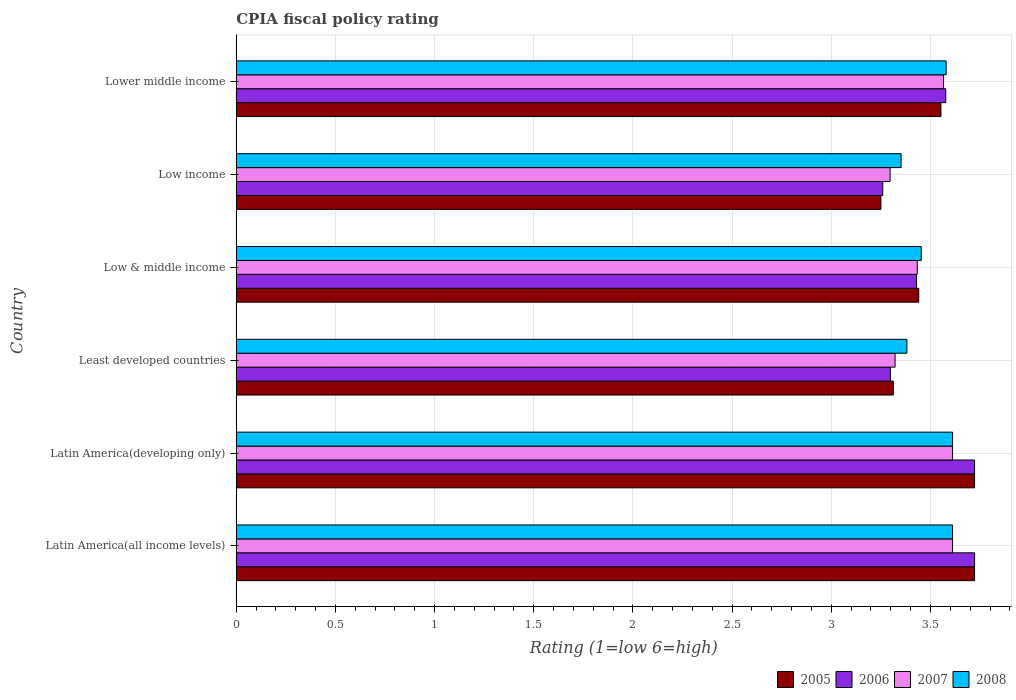How many different coloured bars are there?
Provide a succinct answer. 4. How many groups of bars are there?
Provide a short and direct response. 6. Are the number of bars on each tick of the Y-axis equal?
Give a very brief answer. Yes. What is the label of the 2nd group of bars from the top?
Provide a succinct answer. Low income. In how many cases, is the number of bars for a given country not equal to the number of legend labels?
Your answer should be very brief. 0. What is the CPIA rating in 2007 in Low income?
Provide a short and direct response. 3.3. Across all countries, what is the maximum CPIA rating in 2007?
Offer a terse response. 3.61. Across all countries, what is the minimum CPIA rating in 2008?
Your answer should be compact. 3.35. In which country was the CPIA rating in 2006 maximum?
Keep it short and to the point. Latin America(all income levels). What is the total CPIA rating in 2008 in the graph?
Provide a short and direct response. 20.99. What is the difference between the CPIA rating in 2005 in Low & middle income and that in Lower middle income?
Give a very brief answer. -0.11. What is the difference between the CPIA rating in 2005 in Latin America(developing only) and the CPIA rating in 2008 in Low income?
Provide a short and direct response. 0.37. What is the average CPIA rating in 2006 per country?
Provide a succinct answer. 3.5. What is the difference between the CPIA rating in 2008 and CPIA rating in 2005 in Lower middle income?
Give a very brief answer. 0.03. In how many countries, is the CPIA rating in 2008 greater than 2.1 ?
Offer a very short reply. 6. What is the ratio of the CPIA rating in 2006 in Latin America(all income levels) to that in Low income?
Your answer should be compact. 1.14. Is the CPIA rating in 2005 in Latin America(all income levels) less than that in Lower middle income?
Give a very brief answer. No. What is the difference between the highest and the second highest CPIA rating in 2007?
Your response must be concise. 0. What is the difference between the highest and the lowest CPIA rating in 2005?
Give a very brief answer. 0.47. Is the sum of the CPIA rating in 2006 in Low income and Lower middle income greater than the maximum CPIA rating in 2005 across all countries?
Give a very brief answer. Yes. Is it the case that in every country, the sum of the CPIA rating in 2008 and CPIA rating in 2006 is greater than the sum of CPIA rating in 2007 and CPIA rating in 2005?
Provide a short and direct response. Yes. What does the 4th bar from the top in Least developed countries represents?
Give a very brief answer. 2005. What is the difference between two consecutive major ticks on the X-axis?
Keep it short and to the point. 0.5. Does the graph contain grids?
Give a very brief answer. Yes. Where does the legend appear in the graph?
Offer a terse response. Bottom right. How are the legend labels stacked?
Offer a very short reply. Horizontal. What is the title of the graph?
Your response must be concise. CPIA fiscal policy rating. What is the Rating (1=low 6=high) of 2005 in Latin America(all income levels)?
Ensure brevity in your answer.  3.72. What is the Rating (1=low 6=high) of 2006 in Latin America(all income levels)?
Offer a terse response. 3.72. What is the Rating (1=low 6=high) of 2007 in Latin America(all income levels)?
Ensure brevity in your answer.  3.61. What is the Rating (1=low 6=high) of 2008 in Latin America(all income levels)?
Offer a very short reply. 3.61. What is the Rating (1=low 6=high) of 2005 in Latin America(developing only)?
Provide a succinct answer. 3.72. What is the Rating (1=low 6=high) in 2006 in Latin America(developing only)?
Provide a short and direct response. 3.72. What is the Rating (1=low 6=high) in 2007 in Latin America(developing only)?
Provide a succinct answer. 3.61. What is the Rating (1=low 6=high) of 2008 in Latin America(developing only)?
Give a very brief answer. 3.61. What is the Rating (1=low 6=high) in 2005 in Least developed countries?
Ensure brevity in your answer.  3.31. What is the Rating (1=low 6=high) in 2006 in Least developed countries?
Make the answer very short. 3.3. What is the Rating (1=low 6=high) in 2007 in Least developed countries?
Your answer should be very brief. 3.32. What is the Rating (1=low 6=high) in 2008 in Least developed countries?
Ensure brevity in your answer.  3.38. What is the Rating (1=low 6=high) in 2005 in Low & middle income?
Provide a succinct answer. 3.44. What is the Rating (1=low 6=high) of 2006 in Low & middle income?
Offer a terse response. 3.43. What is the Rating (1=low 6=high) in 2007 in Low & middle income?
Offer a very short reply. 3.43. What is the Rating (1=low 6=high) in 2008 in Low & middle income?
Offer a very short reply. 3.45. What is the Rating (1=low 6=high) in 2005 in Low income?
Provide a succinct answer. 3.25. What is the Rating (1=low 6=high) of 2006 in Low income?
Your answer should be very brief. 3.26. What is the Rating (1=low 6=high) of 2007 in Low income?
Provide a succinct answer. 3.3. What is the Rating (1=low 6=high) in 2008 in Low income?
Keep it short and to the point. 3.35. What is the Rating (1=low 6=high) in 2005 in Lower middle income?
Provide a short and direct response. 3.55. What is the Rating (1=low 6=high) in 2006 in Lower middle income?
Give a very brief answer. 3.58. What is the Rating (1=low 6=high) of 2007 in Lower middle income?
Keep it short and to the point. 3.57. What is the Rating (1=low 6=high) in 2008 in Lower middle income?
Your answer should be very brief. 3.58. Across all countries, what is the maximum Rating (1=low 6=high) in 2005?
Give a very brief answer. 3.72. Across all countries, what is the maximum Rating (1=low 6=high) of 2006?
Make the answer very short. 3.72. Across all countries, what is the maximum Rating (1=low 6=high) in 2007?
Offer a very short reply. 3.61. Across all countries, what is the maximum Rating (1=low 6=high) of 2008?
Give a very brief answer. 3.61. Across all countries, what is the minimum Rating (1=low 6=high) of 2006?
Ensure brevity in your answer.  3.26. Across all countries, what is the minimum Rating (1=low 6=high) of 2007?
Your answer should be very brief. 3.3. Across all countries, what is the minimum Rating (1=low 6=high) in 2008?
Your answer should be compact. 3.35. What is the total Rating (1=low 6=high) of 2005 in the graph?
Offer a very short reply. 21. What is the total Rating (1=low 6=high) in 2006 in the graph?
Your answer should be very brief. 21.01. What is the total Rating (1=low 6=high) of 2007 in the graph?
Provide a short and direct response. 20.84. What is the total Rating (1=low 6=high) of 2008 in the graph?
Offer a very short reply. 20.99. What is the difference between the Rating (1=low 6=high) of 2006 in Latin America(all income levels) and that in Latin America(developing only)?
Offer a very short reply. 0. What is the difference between the Rating (1=low 6=high) of 2008 in Latin America(all income levels) and that in Latin America(developing only)?
Provide a short and direct response. 0. What is the difference between the Rating (1=low 6=high) in 2005 in Latin America(all income levels) and that in Least developed countries?
Give a very brief answer. 0.41. What is the difference between the Rating (1=low 6=high) of 2006 in Latin America(all income levels) and that in Least developed countries?
Your answer should be very brief. 0.42. What is the difference between the Rating (1=low 6=high) in 2007 in Latin America(all income levels) and that in Least developed countries?
Your answer should be compact. 0.29. What is the difference between the Rating (1=low 6=high) in 2008 in Latin America(all income levels) and that in Least developed countries?
Provide a short and direct response. 0.23. What is the difference between the Rating (1=low 6=high) of 2005 in Latin America(all income levels) and that in Low & middle income?
Your response must be concise. 0.28. What is the difference between the Rating (1=low 6=high) of 2006 in Latin America(all income levels) and that in Low & middle income?
Provide a succinct answer. 0.29. What is the difference between the Rating (1=low 6=high) in 2007 in Latin America(all income levels) and that in Low & middle income?
Make the answer very short. 0.18. What is the difference between the Rating (1=low 6=high) of 2008 in Latin America(all income levels) and that in Low & middle income?
Make the answer very short. 0.16. What is the difference between the Rating (1=low 6=high) in 2005 in Latin America(all income levels) and that in Low income?
Ensure brevity in your answer.  0.47. What is the difference between the Rating (1=low 6=high) of 2006 in Latin America(all income levels) and that in Low income?
Offer a very short reply. 0.46. What is the difference between the Rating (1=low 6=high) of 2007 in Latin America(all income levels) and that in Low income?
Your answer should be very brief. 0.31. What is the difference between the Rating (1=low 6=high) in 2008 in Latin America(all income levels) and that in Low income?
Offer a terse response. 0.26. What is the difference between the Rating (1=low 6=high) in 2005 in Latin America(all income levels) and that in Lower middle income?
Your answer should be very brief. 0.17. What is the difference between the Rating (1=low 6=high) in 2006 in Latin America(all income levels) and that in Lower middle income?
Offer a terse response. 0.15. What is the difference between the Rating (1=low 6=high) in 2007 in Latin America(all income levels) and that in Lower middle income?
Your response must be concise. 0.05. What is the difference between the Rating (1=low 6=high) of 2008 in Latin America(all income levels) and that in Lower middle income?
Provide a succinct answer. 0.03. What is the difference between the Rating (1=low 6=high) in 2005 in Latin America(developing only) and that in Least developed countries?
Your answer should be compact. 0.41. What is the difference between the Rating (1=low 6=high) in 2006 in Latin America(developing only) and that in Least developed countries?
Keep it short and to the point. 0.42. What is the difference between the Rating (1=low 6=high) of 2007 in Latin America(developing only) and that in Least developed countries?
Keep it short and to the point. 0.29. What is the difference between the Rating (1=low 6=high) in 2008 in Latin America(developing only) and that in Least developed countries?
Offer a very short reply. 0.23. What is the difference between the Rating (1=low 6=high) of 2005 in Latin America(developing only) and that in Low & middle income?
Offer a terse response. 0.28. What is the difference between the Rating (1=low 6=high) in 2006 in Latin America(developing only) and that in Low & middle income?
Provide a succinct answer. 0.29. What is the difference between the Rating (1=low 6=high) in 2007 in Latin America(developing only) and that in Low & middle income?
Offer a terse response. 0.18. What is the difference between the Rating (1=low 6=high) in 2008 in Latin America(developing only) and that in Low & middle income?
Offer a very short reply. 0.16. What is the difference between the Rating (1=low 6=high) in 2005 in Latin America(developing only) and that in Low income?
Your answer should be very brief. 0.47. What is the difference between the Rating (1=low 6=high) in 2006 in Latin America(developing only) and that in Low income?
Your answer should be compact. 0.46. What is the difference between the Rating (1=low 6=high) in 2007 in Latin America(developing only) and that in Low income?
Your response must be concise. 0.31. What is the difference between the Rating (1=low 6=high) in 2008 in Latin America(developing only) and that in Low income?
Offer a terse response. 0.26. What is the difference between the Rating (1=low 6=high) in 2005 in Latin America(developing only) and that in Lower middle income?
Keep it short and to the point. 0.17. What is the difference between the Rating (1=low 6=high) in 2006 in Latin America(developing only) and that in Lower middle income?
Keep it short and to the point. 0.15. What is the difference between the Rating (1=low 6=high) of 2007 in Latin America(developing only) and that in Lower middle income?
Offer a very short reply. 0.05. What is the difference between the Rating (1=low 6=high) in 2008 in Latin America(developing only) and that in Lower middle income?
Offer a terse response. 0.03. What is the difference between the Rating (1=low 6=high) of 2005 in Least developed countries and that in Low & middle income?
Ensure brevity in your answer.  -0.13. What is the difference between the Rating (1=low 6=high) in 2006 in Least developed countries and that in Low & middle income?
Ensure brevity in your answer.  -0.13. What is the difference between the Rating (1=low 6=high) in 2007 in Least developed countries and that in Low & middle income?
Provide a succinct answer. -0.11. What is the difference between the Rating (1=low 6=high) of 2008 in Least developed countries and that in Low & middle income?
Offer a terse response. -0.07. What is the difference between the Rating (1=low 6=high) of 2005 in Least developed countries and that in Low income?
Offer a terse response. 0.06. What is the difference between the Rating (1=low 6=high) in 2006 in Least developed countries and that in Low income?
Make the answer very short. 0.04. What is the difference between the Rating (1=low 6=high) in 2007 in Least developed countries and that in Low income?
Make the answer very short. 0.03. What is the difference between the Rating (1=low 6=high) in 2008 in Least developed countries and that in Low income?
Make the answer very short. 0.03. What is the difference between the Rating (1=low 6=high) in 2005 in Least developed countries and that in Lower middle income?
Offer a very short reply. -0.24. What is the difference between the Rating (1=low 6=high) of 2006 in Least developed countries and that in Lower middle income?
Ensure brevity in your answer.  -0.28. What is the difference between the Rating (1=low 6=high) in 2007 in Least developed countries and that in Lower middle income?
Make the answer very short. -0.24. What is the difference between the Rating (1=low 6=high) of 2008 in Least developed countries and that in Lower middle income?
Your answer should be compact. -0.2. What is the difference between the Rating (1=low 6=high) of 2005 in Low & middle income and that in Low income?
Keep it short and to the point. 0.19. What is the difference between the Rating (1=low 6=high) of 2006 in Low & middle income and that in Low income?
Provide a short and direct response. 0.17. What is the difference between the Rating (1=low 6=high) in 2007 in Low & middle income and that in Low income?
Ensure brevity in your answer.  0.14. What is the difference between the Rating (1=low 6=high) in 2008 in Low & middle income and that in Low income?
Provide a succinct answer. 0.1. What is the difference between the Rating (1=low 6=high) of 2005 in Low & middle income and that in Lower middle income?
Offer a very short reply. -0.11. What is the difference between the Rating (1=low 6=high) of 2006 in Low & middle income and that in Lower middle income?
Your answer should be very brief. -0.15. What is the difference between the Rating (1=low 6=high) of 2007 in Low & middle income and that in Lower middle income?
Your answer should be compact. -0.13. What is the difference between the Rating (1=low 6=high) of 2008 in Low & middle income and that in Lower middle income?
Your response must be concise. -0.13. What is the difference between the Rating (1=low 6=high) in 2005 in Low income and that in Lower middle income?
Your response must be concise. -0.3. What is the difference between the Rating (1=low 6=high) in 2006 in Low income and that in Lower middle income?
Ensure brevity in your answer.  -0.32. What is the difference between the Rating (1=low 6=high) of 2007 in Low income and that in Lower middle income?
Keep it short and to the point. -0.27. What is the difference between the Rating (1=low 6=high) in 2008 in Low income and that in Lower middle income?
Give a very brief answer. -0.23. What is the difference between the Rating (1=low 6=high) in 2005 in Latin America(all income levels) and the Rating (1=low 6=high) in 2006 in Latin America(developing only)?
Offer a very short reply. 0. What is the difference between the Rating (1=low 6=high) of 2005 in Latin America(all income levels) and the Rating (1=low 6=high) of 2006 in Least developed countries?
Your answer should be very brief. 0.42. What is the difference between the Rating (1=low 6=high) in 2005 in Latin America(all income levels) and the Rating (1=low 6=high) in 2007 in Least developed countries?
Your answer should be compact. 0.4. What is the difference between the Rating (1=low 6=high) in 2005 in Latin America(all income levels) and the Rating (1=low 6=high) in 2008 in Least developed countries?
Provide a succinct answer. 0.34. What is the difference between the Rating (1=low 6=high) in 2006 in Latin America(all income levels) and the Rating (1=low 6=high) in 2007 in Least developed countries?
Your answer should be very brief. 0.4. What is the difference between the Rating (1=low 6=high) in 2006 in Latin America(all income levels) and the Rating (1=low 6=high) in 2008 in Least developed countries?
Make the answer very short. 0.34. What is the difference between the Rating (1=low 6=high) of 2007 in Latin America(all income levels) and the Rating (1=low 6=high) of 2008 in Least developed countries?
Provide a short and direct response. 0.23. What is the difference between the Rating (1=low 6=high) in 2005 in Latin America(all income levels) and the Rating (1=low 6=high) in 2006 in Low & middle income?
Offer a terse response. 0.29. What is the difference between the Rating (1=low 6=high) in 2005 in Latin America(all income levels) and the Rating (1=low 6=high) in 2007 in Low & middle income?
Your answer should be very brief. 0.29. What is the difference between the Rating (1=low 6=high) in 2005 in Latin America(all income levels) and the Rating (1=low 6=high) in 2008 in Low & middle income?
Make the answer very short. 0.27. What is the difference between the Rating (1=low 6=high) of 2006 in Latin America(all income levels) and the Rating (1=low 6=high) of 2007 in Low & middle income?
Offer a terse response. 0.29. What is the difference between the Rating (1=low 6=high) in 2006 in Latin America(all income levels) and the Rating (1=low 6=high) in 2008 in Low & middle income?
Keep it short and to the point. 0.27. What is the difference between the Rating (1=low 6=high) in 2007 in Latin America(all income levels) and the Rating (1=low 6=high) in 2008 in Low & middle income?
Make the answer very short. 0.16. What is the difference between the Rating (1=low 6=high) of 2005 in Latin America(all income levels) and the Rating (1=low 6=high) of 2006 in Low income?
Give a very brief answer. 0.46. What is the difference between the Rating (1=low 6=high) of 2005 in Latin America(all income levels) and the Rating (1=low 6=high) of 2007 in Low income?
Your answer should be compact. 0.43. What is the difference between the Rating (1=low 6=high) in 2005 in Latin America(all income levels) and the Rating (1=low 6=high) in 2008 in Low income?
Your response must be concise. 0.37. What is the difference between the Rating (1=low 6=high) of 2006 in Latin America(all income levels) and the Rating (1=low 6=high) of 2007 in Low income?
Give a very brief answer. 0.43. What is the difference between the Rating (1=low 6=high) of 2006 in Latin America(all income levels) and the Rating (1=low 6=high) of 2008 in Low income?
Ensure brevity in your answer.  0.37. What is the difference between the Rating (1=low 6=high) in 2007 in Latin America(all income levels) and the Rating (1=low 6=high) in 2008 in Low income?
Your answer should be very brief. 0.26. What is the difference between the Rating (1=low 6=high) in 2005 in Latin America(all income levels) and the Rating (1=low 6=high) in 2006 in Lower middle income?
Make the answer very short. 0.15. What is the difference between the Rating (1=low 6=high) in 2005 in Latin America(all income levels) and the Rating (1=low 6=high) in 2007 in Lower middle income?
Ensure brevity in your answer.  0.16. What is the difference between the Rating (1=low 6=high) in 2005 in Latin America(all income levels) and the Rating (1=low 6=high) in 2008 in Lower middle income?
Provide a succinct answer. 0.14. What is the difference between the Rating (1=low 6=high) in 2006 in Latin America(all income levels) and the Rating (1=low 6=high) in 2007 in Lower middle income?
Your answer should be compact. 0.16. What is the difference between the Rating (1=low 6=high) of 2006 in Latin America(all income levels) and the Rating (1=low 6=high) of 2008 in Lower middle income?
Your answer should be compact. 0.14. What is the difference between the Rating (1=low 6=high) in 2007 in Latin America(all income levels) and the Rating (1=low 6=high) in 2008 in Lower middle income?
Your response must be concise. 0.03. What is the difference between the Rating (1=low 6=high) of 2005 in Latin America(developing only) and the Rating (1=low 6=high) of 2006 in Least developed countries?
Keep it short and to the point. 0.42. What is the difference between the Rating (1=low 6=high) of 2005 in Latin America(developing only) and the Rating (1=low 6=high) of 2007 in Least developed countries?
Offer a very short reply. 0.4. What is the difference between the Rating (1=low 6=high) in 2005 in Latin America(developing only) and the Rating (1=low 6=high) in 2008 in Least developed countries?
Give a very brief answer. 0.34. What is the difference between the Rating (1=low 6=high) in 2006 in Latin America(developing only) and the Rating (1=low 6=high) in 2007 in Least developed countries?
Offer a very short reply. 0.4. What is the difference between the Rating (1=low 6=high) in 2006 in Latin America(developing only) and the Rating (1=low 6=high) in 2008 in Least developed countries?
Give a very brief answer. 0.34. What is the difference between the Rating (1=low 6=high) in 2007 in Latin America(developing only) and the Rating (1=low 6=high) in 2008 in Least developed countries?
Your answer should be very brief. 0.23. What is the difference between the Rating (1=low 6=high) of 2005 in Latin America(developing only) and the Rating (1=low 6=high) of 2006 in Low & middle income?
Keep it short and to the point. 0.29. What is the difference between the Rating (1=low 6=high) of 2005 in Latin America(developing only) and the Rating (1=low 6=high) of 2007 in Low & middle income?
Make the answer very short. 0.29. What is the difference between the Rating (1=low 6=high) of 2005 in Latin America(developing only) and the Rating (1=low 6=high) of 2008 in Low & middle income?
Give a very brief answer. 0.27. What is the difference between the Rating (1=low 6=high) of 2006 in Latin America(developing only) and the Rating (1=low 6=high) of 2007 in Low & middle income?
Give a very brief answer. 0.29. What is the difference between the Rating (1=low 6=high) in 2006 in Latin America(developing only) and the Rating (1=low 6=high) in 2008 in Low & middle income?
Offer a terse response. 0.27. What is the difference between the Rating (1=low 6=high) in 2007 in Latin America(developing only) and the Rating (1=low 6=high) in 2008 in Low & middle income?
Your answer should be compact. 0.16. What is the difference between the Rating (1=low 6=high) of 2005 in Latin America(developing only) and the Rating (1=low 6=high) of 2006 in Low income?
Offer a very short reply. 0.46. What is the difference between the Rating (1=low 6=high) in 2005 in Latin America(developing only) and the Rating (1=low 6=high) in 2007 in Low income?
Your answer should be compact. 0.43. What is the difference between the Rating (1=low 6=high) of 2005 in Latin America(developing only) and the Rating (1=low 6=high) of 2008 in Low income?
Offer a very short reply. 0.37. What is the difference between the Rating (1=low 6=high) in 2006 in Latin America(developing only) and the Rating (1=low 6=high) in 2007 in Low income?
Your response must be concise. 0.43. What is the difference between the Rating (1=low 6=high) in 2006 in Latin America(developing only) and the Rating (1=low 6=high) in 2008 in Low income?
Provide a succinct answer. 0.37. What is the difference between the Rating (1=low 6=high) of 2007 in Latin America(developing only) and the Rating (1=low 6=high) of 2008 in Low income?
Offer a very short reply. 0.26. What is the difference between the Rating (1=low 6=high) of 2005 in Latin America(developing only) and the Rating (1=low 6=high) of 2006 in Lower middle income?
Offer a very short reply. 0.15. What is the difference between the Rating (1=low 6=high) of 2005 in Latin America(developing only) and the Rating (1=low 6=high) of 2007 in Lower middle income?
Your answer should be compact. 0.16. What is the difference between the Rating (1=low 6=high) in 2005 in Latin America(developing only) and the Rating (1=low 6=high) in 2008 in Lower middle income?
Provide a short and direct response. 0.14. What is the difference between the Rating (1=low 6=high) in 2006 in Latin America(developing only) and the Rating (1=low 6=high) in 2007 in Lower middle income?
Your answer should be very brief. 0.16. What is the difference between the Rating (1=low 6=high) in 2006 in Latin America(developing only) and the Rating (1=low 6=high) in 2008 in Lower middle income?
Keep it short and to the point. 0.14. What is the difference between the Rating (1=low 6=high) of 2007 in Latin America(developing only) and the Rating (1=low 6=high) of 2008 in Lower middle income?
Keep it short and to the point. 0.03. What is the difference between the Rating (1=low 6=high) of 2005 in Least developed countries and the Rating (1=low 6=high) of 2006 in Low & middle income?
Offer a terse response. -0.12. What is the difference between the Rating (1=low 6=high) in 2005 in Least developed countries and the Rating (1=low 6=high) in 2007 in Low & middle income?
Your response must be concise. -0.12. What is the difference between the Rating (1=low 6=high) in 2005 in Least developed countries and the Rating (1=low 6=high) in 2008 in Low & middle income?
Give a very brief answer. -0.14. What is the difference between the Rating (1=low 6=high) in 2006 in Least developed countries and the Rating (1=low 6=high) in 2007 in Low & middle income?
Provide a short and direct response. -0.14. What is the difference between the Rating (1=low 6=high) of 2006 in Least developed countries and the Rating (1=low 6=high) of 2008 in Low & middle income?
Give a very brief answer. -0.16. What is the difference between the Rating (1=low 6=high) of 2007 in Least developed countries and the Rating (1=low 6=high) of 2008 in Low & middle income?
Keep it short and to the point. -0.13. What is the difference between the Rating (1=low 6=high) in 2005 in Least developed countries and the Rating (1=low 6=high) in 2006 in Low income?
Your answer should be very brief. 0.05. What is the difference between the Rating (1=low 6=high) of 2005 in Least developed countries and the Rating (1=low 6=high) of 2007 in Low income?
Provide a short and direct response. 0.02. What is the difference between the Rating (1=low 6=high) of 2005 in Least developed countries and the Rating (1=low 6=high) of 2008 in Low income?
Keep it short and to the point. -0.04. What is the difference between the Rating (1=low 6=high) of 2006 in Least developed countries and the Rating (1=low 6=high) of 2007 in Low income?
Ensure brevity in your answer.  0. What is the difference between the Rating (1=low 6=high) in 2006 in Least developed countries and the Rating (1=low 6=high) in 2008 in Low income?
Your response must be concise. -0.05. What is the difference between the Rating (1=low 6=high) in 2007 in Least developed countries and the Rating (1=low 6=high) in 2008 in Low income?
Ensure brevity in your answer.  -0.03. What is the difference between the Rating (1=low 6=high) of 2005 in Least developed countries and the Rating (1=low 6=high) of 2006 in Lower middle income?
Ensure brevity in your answer.  -0.26. What is the difference between the Rating (1=low 6=high) in 2005 in Least developed countries and the Rating (1=low 6=high) in 2007 in Lower middle income?
Give a very brief answer. -0.25. What is the difference between the Rating (1=low 6=high) in 2005 in Least developed countries and the Rating (1=low 6=high) in 2008 in Lower middle income?
Keep it short and to the point. -0.27. What is the difference between the Rating (1=low 6=high) in 2006 in Least developed countries and the Rating (1=low 6=high) in 2007 in Lower middle income?
Give a very brief answer. -0.27. What is the difference between the Rating (1=low 6=high) in 2006 in Least developed countries and the Rating (1=low 6=high) in 2008 in Lower middle income?
Your answer should be compact. -0.28. What is the difference between the Rating (1=low 6=high) of 2007 in Least developed countries and the Rating (1=low 6=high) of 2008 in Lower middle income?
Ensure brevity in your answer.  -0.26. What is the difference between the Rating (1=low 6=high) in 2005 in Low & middle income and the Rating (1=low 6=high) in 2006 in Low income?
Keep it short and to the point. 0.18. What is the difference between the Rating (1=low 6=high) in 2005 in Low & middle income and the Rating (1=low 6=high) in 2007 in Low income?
Ensure brevity in your answer.  0.14. What is the difference between the Rating (1=low 6=high) of 2005 in Low & middle income and the Rating (1=low 6=high) of 2008 in Low income?
Keep it short and to the point. 0.09. What is the difference between the Rating (1=low 6=high) of 2006 in Low & middle income and the Rating (1=low 6=high) of 2007 in Low income?
Keep it short and to the point. 0.13. What is the difference between the Rating (1=low 6=high) of 2006 in Low & middle income and the Rating (1=low 6=high) of 2008 in Low income?
Your answer should be compact. 0.08. What is the difference between the Rating (1=low 6=high) of 2007 in Low & middle income and the Rating (1=low 6=high) of 2008 in Low income?
Offer a very short reply. 0.08. What is the difference between the Rating (1=low 6=high) of 2005 in Low & middle income and the Rating (1=low 6=high) of 2006 in Lower middle income?
Provide a short and direct response. -0.14. What is the difference between the Rating (1=low 6=high) in 2005 in Low & middle income and the Rating (1=low 6=high) in 2007 in Lower middle income?
Make the answer very short. -0.12. What is the difference between the Rating (1=low 6=high) in 2005 in Low & middle income and the Rating (1=low 6=high) in 2008 in Lower middle income?
Make the answer very short. -0.14. What is the difference between the Rating (1=low 6=high) in 2006 in Low & middle income and the Rating (1=low 6=high) in 2007 in Lower middle income?
Make the answer very short. -0.14. What is the difference between the Rating (1=low 6=high) in 2006 in Low & middle income and the Rating (1=low 6=high) in 2008 in Lower middle income?
Your answer should be very brief. -0.15. What is the difference between the Rating (1=low 6=high) of 2007 in Low & middle income and the Rating (1=low 6=high) of 2008 in Lower middle income?
Provide a succinct answer. -0.15. What is the difference between the Rating (1=low 6=high) in 2005 in Low income and the Rating (1=low 6=high) in 2006 in Lower middle income?
Provide a short and direct response. -0.33. What is the difference between the Rating (1=low 6=high) of 2005 in Low income and the Rating (1=low 6=high) of 2007 in Lower middle income?
Your response must be concise. -0.32. What is the difference between the Rating (1=low 6=high) of 2005 in Low income and the Rating (1=low 6=high) of 2008 in Lower middle income?
Give a very brief answer. -0.33. What is the difference between the Rating (1=low 6=high) of 2006 in Low income and the Rating (1=low 6=high) of 2007 in Lower middle income?
Keep it short and to the point. -0.31. What is the difference between the Rating (1=low 6=high) of 2006 in Low income and the Rating (1=low 6=high) of 2008 in Lower middle income?
Your answer should be very brief. -0.32. What is the difference between the Rating (1=low 6=high) in 2007 in Low income and the Rating (1=low 6=high) in 2008 in Lower middle income?
Make the answer very short. -0.28. What is the average Rating (1=low 6=high) of 2005 per country?
Your answer should be very brief. 3.5. What is the average Rating (1=low 6=high) in 2006 per country?
Offer a very short reply. 3.5. What is the average Rating (1=low 6=high) in 2007 per country?
Your answer should be compact. 3.47. What is the average Rating (1=low 6=high) of 2008 per country?
Provide a short and direct response. 3.5. What is the difference between the Rating (1=low 6=high) of 2005 and Rating (1=low 6=high) of 2007 in Latin America(all income levels)?
Offer a terse response. 0.11. What is the difference between the Rating (1=low 6=high) of 2005 and Rating (1=low 6=high) of 2006 in Latin America(developing only)?
Provide a short and direct response. 0. What is the difference between the Rating (1=low 6=high) of 2005 and Rating (1=low 6=high) of 2007 in Latin America(developing only)?
Your answer should be very brief. 0.11. What is the difference between the Rating (1=low 6=high) of 2005 and Rating (1=low 6=high) of 2008 in Latin America(developing only)?
Provide a succinct answer. 0.11. What is the difference between the Rating (1=low 6=high) of 2006 and Rating (1=low 6=high) of 2008 in Latin America(developing only)?
Offer a terse response. 0.11. What is the difference between the Rating (1=low 6=high) of 2007 and Rating (1=low 6=high) of 2008 in Latin America(developing only)?
Provide a short and direct response. 0. What is the difference between the Rating (1=low 6=high) in 2005 and Rating (1=low 6=high) in 2006 in Least developed countries?
Your response must be concise. 0.01. What is the difference between the Rating (1=low 6=high) in 2005 and Rating (1=low 6=high) in 2007 in Least developed countries?
Provide a succinct answer. -0.01. What is the difference between the Rating (1=low 6=high) of 2005 and Rating (1=low 6=high) of 2008 in Least developed countries?
Give a very brief answer. -0.07. What is the difference between the Rating (1=low 6=high) of 2006 and Rating (1=low 6=high) of 2007 in Least developed countries?
Your response must be concise. -0.02. What is the difference between the Rating (1=low 6=high) of 2006 and Rating (1=low 6=high) of 2008 in Least developed countries?
Make the answer very short. -0.08. What is the difference between the Rating (1=low 6=high) of 2007 and Rating (1=low 6=high) of 2008 in Least developed countries?
Your answer should be compact. -0.06. What is the difference between the Rating (1=low 6=high) of 2005 and Rating (1=low 6=high) of 2006 in Low & middle income?
Make the answer very short. 0.01. What is the difference between the Rating (1=low 6=high) of 2005 and Rating (1=low 6=high) of 2007 in Low & middle income?
Provide a short and direct response. 0.01. What is the difference between the Rating (1=low 6=high) of 2005 and Rating (1=low 6=high) of 2008 in Low & middle income?
Provide a short and direct response. -0.01. What is the difference between the Rating (1=low 6=high) of 2006 and Rating (1=low 6=high) of 2007 in Low & middle income?
Your answer should be very brief. -0. What is the difference between the Rating (1=low 6=high) of 2006 and Rating (1=low 6=high) of 2008 in Low & middle income?
Keep it short and to the point. -0.02. What is the difference between the Rating (1=low 6=high) of 2007 and Rating (1=low 6=high) of 2008 in Low & middle income?
Make the answer very short. -0.02. What is the difference between the Rating (1=low 6=high) of 2005 and Rating (1=low 6=high) of 2006 in Low income?
Offer a terse response. -0.01. What is the difference between the Rating (1=low 6=high) in 2005 and Rating (1=low 6=high) in 2007 in Low income?
Your response must be concise. -0.05. What is the difference between the Rating (1=low 6=high) in 2005 and Rating (1=low 6=high) in 2008 in Low income?
Keep it short and to the point. -0.1. What is the difference between the Rating (1=low 6=high) in 2006 and Rating (1=low 6=high) in 2007 in Low income?
Offer a terse response. -0.04. What is the difference between the Rating (1=low 6=high) of 2006 and Rating (1=low 6=high) of 2008 in Low income?
Offer a very short reply. -0.09. What is the difference between the Rating (1=low 6=high) of 2007 and Rating (1=low 6=high) of 2008 in Low income?
Give a very brief answer. -0.06. What is the difference between the Rating (1=low 6=high) in 2005 and Rating (1=low 6=high) in 2006 in Lower middle income?
Ensure brevity in your answer.  -0.02. What is the difference between the Rating (1=low 6=high) in 2005 and Rating (1=low 6=high) in 2007 in Lower middle income?
Provide a succinct answer. -0.01. What is the difference between the Rating (1=low 6=high) in 2005 and Rating (1=low 6=high) in 2008 in Lower middle income?
Give a very brief answer. -0.03. What is the difference between the Rating (1=low 6=high) of 2006 and Rating (1=low 6=high) of 2007 in Lower middle income?
Ensure brevity in your answer.  0.01. What is the difference between the Rating (1=low 6=high) in 2006 and Rating (1=low 6=high) in 2008 in Lower middle income?
Your answer should be compact. -0. What is the difference between the Rating (1=low 6=high) of 2007 and Rating (1=low 6=high) of 2008 in Lower middle income?
Your answer should be very brief. -0.01. What is the ratio of the Rating (1=low 6=high) in 2005 in Latin America(all income levels) to that in Latin America(developing only)?
Make the answer very short. 1. What is the ratio of the Rating (1=low 6=high) of 2006 in Latin America(all income levels) to that in Latin America(developing only)?
Keep it short and to the point. 1. What is the ratio of the Rating (1=low 6=high) of 2008 in Latin America(all income levels) to that in Latin America(developing only)?
Offer a terse response. 1. What is the ratio of the Rating (1=low 6=high) of 2005 in Latin America(all income levels) to that in Least developed countries?
Offer a terse response. 1.12. What is the ratio of the Rating (1=low 6=high) in 2006 in Latin America(all income levels) to that in Least developed countries?
Ensure brevity in your answer.  1.13. What is the ratio of the Rating (1=low 6=high) of 2007 in Latin America(all income levels) to that in Least developed countries?
Give a very brief answer. 1.09. What is the ratio of the Rating (1=low 6=high) in 2008 in Latin America(all income levels) to that in Least developed countries?
Provide a short and direct response. 1.07. What is the ratio of the Rating (1=low 6=high) in 2005 in Latin America(all income levels) to that in Low & middle income?
Your answer should be compact. 1.08. What is the ratio of the Rating (1=low 6=high) in 2006 in Latin America(all income levels) to that in Low & middle income?
Keep it short and to the point. 1.09. What is the ratio of the Rating (1=low 6=high) of 2007 in Latin America(all income levels) to that in Low & middle income?
Provide a short and direct response. 1.05. What is the ratio of the Rating (1=low 6=high) in 2008 in Latin America(all income levels) to that in Low & middle income?
Your response must be concise. 1.05. What is the ratio of the Rating (1=low 6=high) in 2005 in Latin America(all income levels) to that in Low income?
Provide a short and direct response. 1.15. What is the ratio of the Rating (1=low 6=high) in 2006 in Latin America(all income levels) to that in Low income?
Your response must be concise. 1.14. What is the ratio of the Rating (1=low 6=high) of 2007 in Latin America(all income levels) to that in Low income?
Provide a short and direct response. 1.1. What is the ratio of the Rating (1=low 6=high) of 2008 in Latin America(all income levels) to that in Low income?
Offer a terse response. 1.08. What is the ratio of the Rating (1=low 6=high) of 2005 in Latin America(all income levels) to that in Lower middle income?
Make the answer very short. 1.05. What is the ratio of the Rating (1=low 6=high) of 2006 in Latin America(all income levels) to that in Lower middle income?
Give a very brief answer. 1.04. What is the ratio of the Rating (1=low 6=high) of 2007 in Latin America(all income levels) to that in Lower middle income?
Offer a very short reply. 1.01. What is the ratio of the Rating (1=low 6=high) of 2005 in Latin America(developing only) to that in Least developed countries?
Your response must be concise. 1.12. What is the ratio of the Rating (1=low 6=high) of 2006 in Latin America(developing only) to that in Least developed countries?
Your answer should be very brief. 1.13. What is the ratio of the Rating (1=low 6=high) of 2007 in Latin America(developing only) to that in Least developed countries?
Your response must be concise. 1.09. What is the ratio of the Rating (1=low 6=high) in 2008 in Latin America(developing only) to that in Least developed countries?
Provide a short and direct response. 1.07. What is the ratio of the Rating (1=low 6=high) of 2005 in Latin America(developing only) to that in Low & middle income?
Provide a short and direct response. 1.08. What is the ratio of the Rating (1=low 6=high) in 2006 in Latin America(developing only) to that in Low & middle income?
Make the answer very short. 1.09. What is the ratio of the Rating (1=low 6=high) of 2007 in Latin America(developing only) to that in Low & middle income?
Ensure brevity in your answer.  1.05. What is the ratio of the Rating (1=low 6=high) in 2008 in Latin America(developing only) to that in Low & middle income?
Provide a short and direct response. 1.05. What is the ratio of the Rating (1=low 6=high) of 2005 in Latin America(developing only) to that in Low income?
Ensure brevity in your answer.  1.15. What is the ratio of the Rating (1=low 6=high) in 2006 in Latin America(developing only) to that in Low income?
Offer a very short reply. 1.14. What is the ratio of the Rating (1=low 6=high) of 2007 in Latin America(developing only) to that in Low income?
Provide a succinct answer. 1.1. What is the ratio of the Rating (1=low 6=high) of 2008 in Latin America(developing only) to that in Low income?
Keep it short and to the point. 1.08. What is the ratio of the Rating (1=low 6=high) of 2005 in Latin America(developing only) to that in Lower middle income?
Offer a terse response. 1.05. What is the ratio of the Rating (1=low 6=high) in 2006 in Latin America(developing only) to that in Lower middle income?
Provide a short and direct response. 1.04. What is the ratio of the Rating (1=low 6=high) in 2007 in Latin America(developing only) to that in Lower middle income?
Provide a short and direct response. 1.01. What is the ratio of the Rating (1=low 6=high) in 2008 in Latin America(developing only) to that in Lower middle income?
Offer a terse response. 1.01. What is the ratio of the Rating (1=low 6=high) of 2005 in Least developed countries to that in Low & middle income?
Your answer should be compact. 0.96. What is the ratio of the Rating (1=low 6=high) of 2006 in Least developed countries to that in Low & middle income?
Keep it short and to the point. 0.96. What is the ratio of the Rating (1=low 6=high) in 2007 in Least developed countries to that in Low & middle income?
Offer a very short reply. 0.97. What is the ratio of the Rating (1=low 6=high) in 2005 in Least developed countries to that in Low income?
Give a very brief answer. 1.02. What is the ratio of the Rating (1=low 6=high) of 2006 in Least developed countries to that in Low income?
Keep it short and to the point. 1.01. What is the ratio of the Rating (1=low 6=high) in 2007 in Least developed countries to that in Low income?
Provide a succinct answer. 1.01. What is the ratio of the Rating (1=low 6=high) of 2008 in Least developed countries to that in Low income?
Your response must be concise. 1.01. What is the ratio of the Rating (1=low 6=high) of 2005 in Least developed countries to that in Lower middle income?
Your answer should be very brief. 0.93. What is the ratio of the Rating (1=low 6=high) in 2006 in Least developed countries to that in Lower middle income?
Offer a very short reply. 0.92. What is the ratio of the Rating (1=low 6=high) of 2007 in Least developed countries to that in Lower middle income?
Give a very brief answer. 0.93. What is the ratio of the Rating (1=low 6=high) of 2008 in Least developed countries to that in Lower middle income?
Your response must be concise. 0.94. What is the ratio of the Rating (1=low 6=high) in 2005 in Low & middle income to that in Low income?
Provide a short and direct response. 1.06. What is the ratio of the Rating (1=low 6=high) of 2006 in Low & middle income to that in Low income?
Make the answer very short. 1.05. What is the ratio of the Rating (1=low 6=high) of 2007 in Low & middle income to that in Low income?
Offer a terse response. 1.04. What is the ratio of the Rating (1=low 6=high) in 2008 in Low & middle income to that in Low income?
Your answer should be compact. 1.03. What is the ratio of the Rating (1=low 6=high) in 2005 in Low & middle income to that in Lower middle income?
Your response must be concise. 0.97. What is the ratio of the Rating (1=low 6=high) in 2006 in Low & middle income to that in Lower middle income?
Your response must be concise. 0.96. What is the ratio of the Rating (1=low 6=high) of 2007 in Low & middle income to that in Lower middle income?
Offer a terse response. 0.96. What is the ratio of the Rating (1=low 6=high) in 2008 in Low & middle income to that in Lower middle income?
Offer a terse response. 0.96. What is the ratio of the Rating (1=low 6=high) of 2005 in Low income to that in Lower middle income?
Provide a succinct answer. 0.91. What is the ratio of the Rating (1=low 6=high) of 2006 in Low income to that in Lower middle income?
Offer a terse response. 0.91. What is the ratio of the Rating (1=low 6=high) of 2007 in Low income to that in Lower middle income?
Ensure brevity in your answer.  0.92. What is the ratio of the Rating (1=low 6=high) in 2008 in Low income to that in Lower middle income?
Offer a very short reply. 0.94. What is the difference between the highest and the lowest Rating (1=low 6=high) in 2005?
Give a very brief answer. 0.47. What is the difference between the highest and the lowest Rating (1=low 6=high) in 2006?
Ensure brevity in your answer.  0.46. What is the difference between the highest and the lowest Rating (1=low 6=high) of 2007?
Ensure brevity in your answer.  0.31. What is the difference between the highest and the lowest Rating (1=low 6=high) in 2008?
Ensure brevity in your answer.  0.26. 